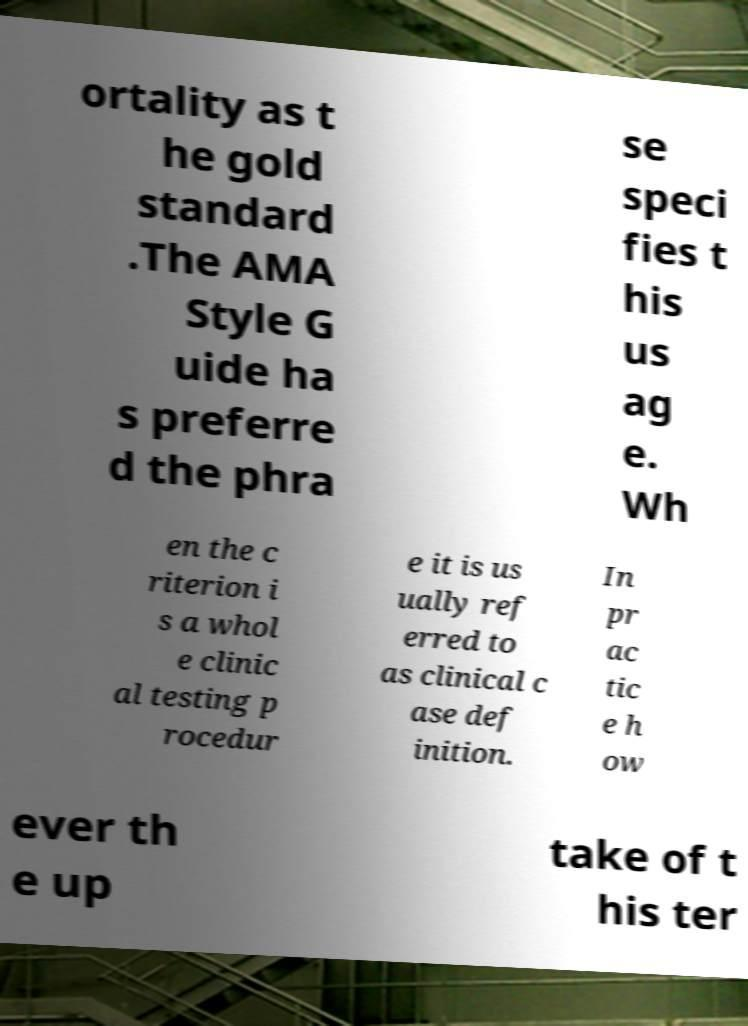Please identify and transcribe the text found in this image. ortality as t he gold standard .The AMA Style G uide ha s preferre d the phra se speci fies t his us ag e. Wh en the c riterion i s a whol e clinic al testing p rocedur e it is us ually ref erred to as clinical c ase def inition. In pr ac tic e h ow ever th e up take of t his ter 